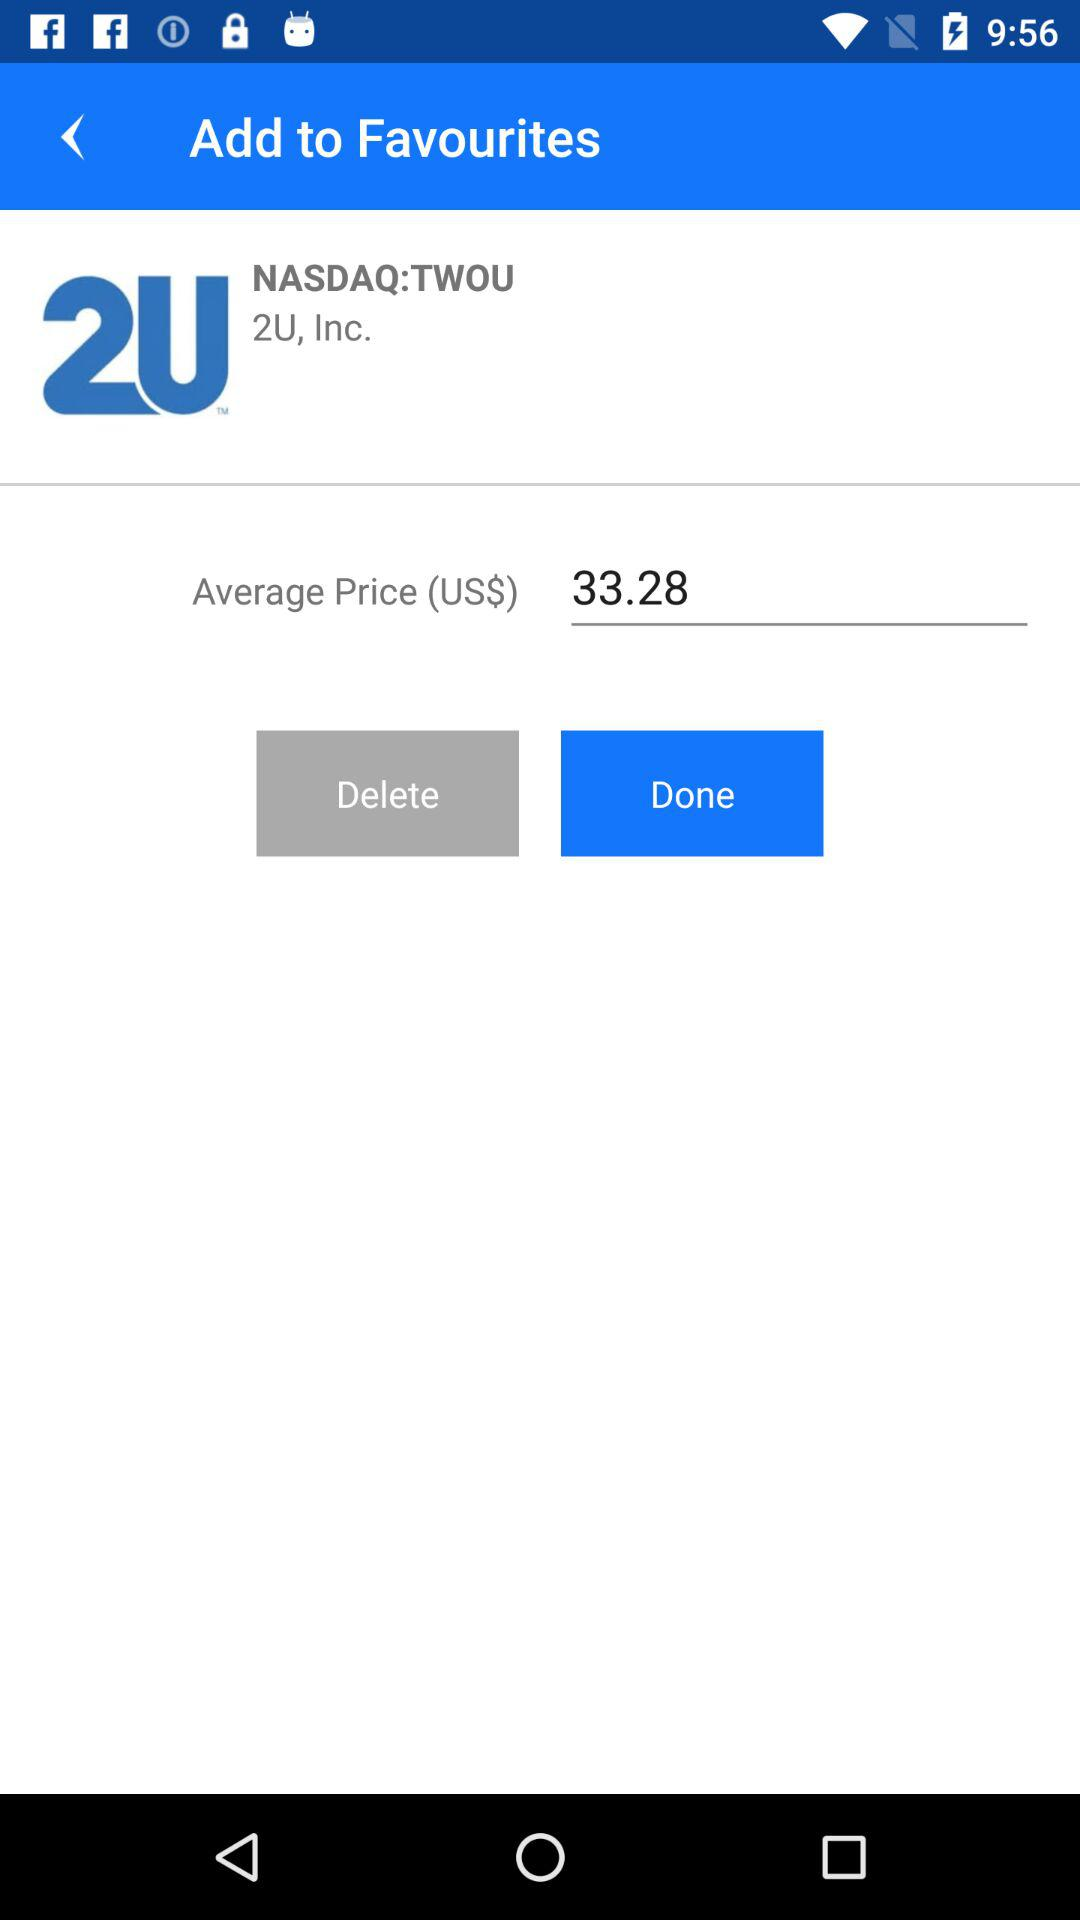What is the currency of the price? The currency of the price is US dollars. 